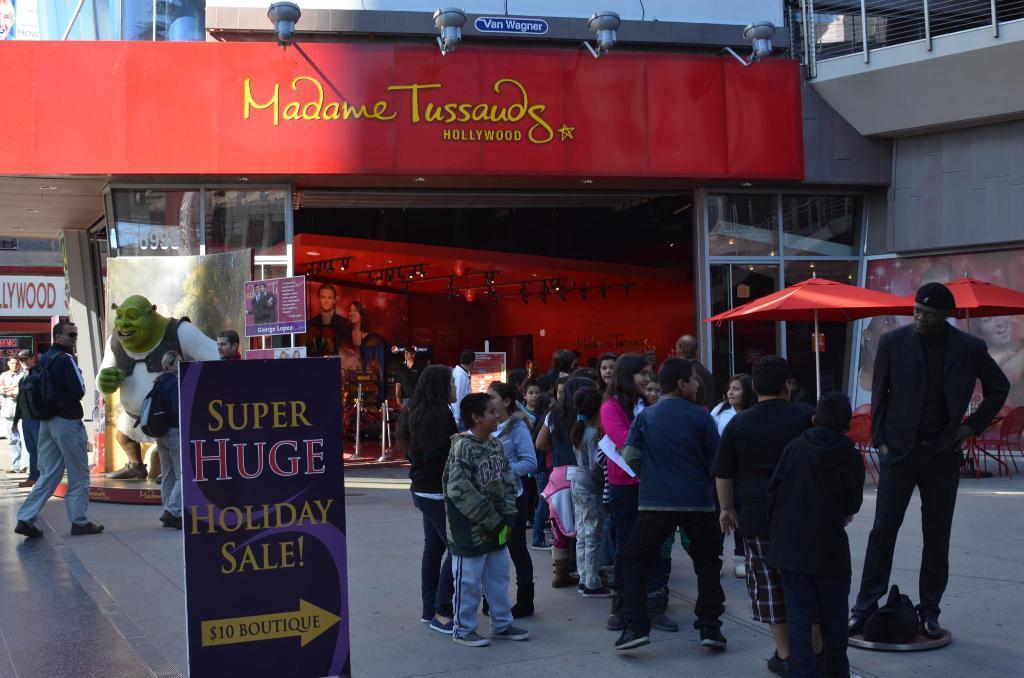How would you summarize this image in a sentence or two? In this image I can see number of persons standing on the floor and a statue of a person wearing black outfit. In the background I can see the building, few tents which are red in color, few boards and a red colored board and few lights. 